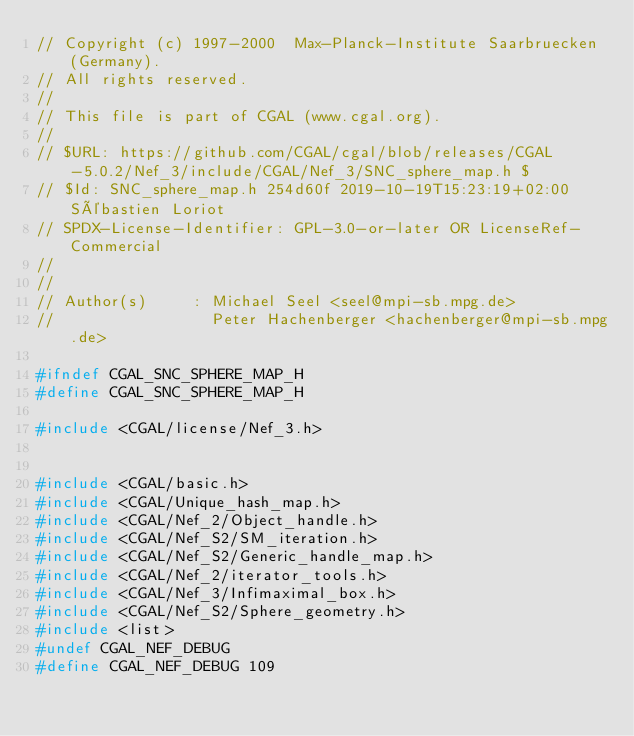Convert code to text. <code><loc_0><loc_0><loc_500><loc_500><_C_>// Copyright (c) 1997-2000  Max-Planck-Institute Saarbruecken (Germany).
// All rights reserved.
//
// This file is part of CGAL (www.cgal.org).
//
// $URL: https://github.com/CGAL/cgal/blob/releases/CGAL-5.0.2/Nef_3/include/CGAL/Nef_3/SNC_sphere_map.h $
// $Id: SNC_sphere_map.h 254d60f 2019-10-19T15:23:19+02:00 Sébastien Loriot
// SPDX-License-Identifier: GPL-3.0-or-later OR LicenseRef-Commercial
// 
//
// Author(s)     : Michael Seel <seel@mpi-sb.mpg.de>
//                 Peter Hachenberger <hachenberger@mpi-sb.mpg.de>

#ifndef CGAL_SNC_SPHERE_MAP_H
#define CGAL_SNC_SPHERE_MAP_H

#include <CGAL/license/Nef_3.h>


#include <CGAL/basic.h>
#include <CGAL/Unique_hash_map.h>
#include <CGAL/Nef_2/Object_handle.h>
#include <CGAL/Nef_S2/SM_iteration.h>
#include <CGAL/Nef_S2/Generic_handle_map.h>
#include <CGAL/Nef_2/iterator_tools.h>
#include <CGAL/Nef_3/Infimaximal_box.h>
#include <CGAL/Nef_S2/Sphere_geometry.h>
#include <list>
#undef CGAL_NEF_DEBUG
#define CGAL_NEF_DEBUG 109</code> 